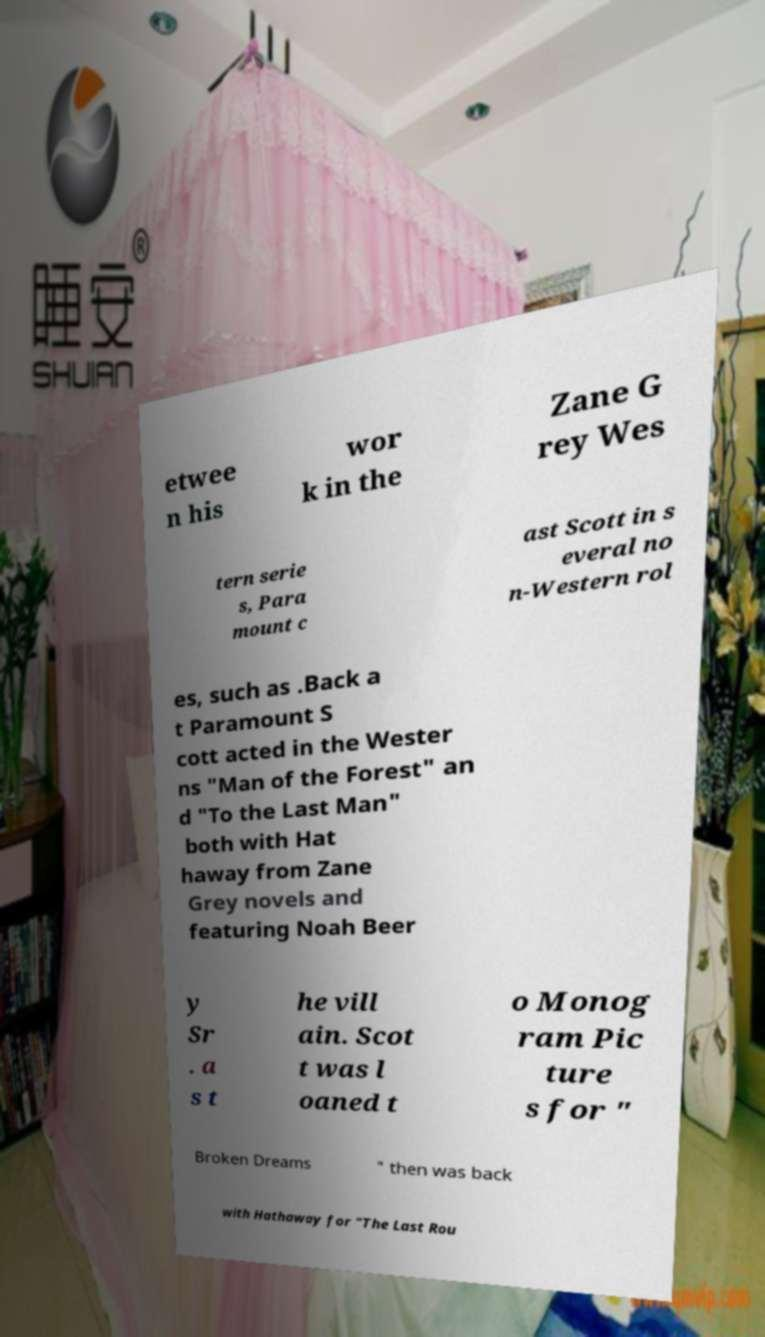There's text embedded in this image that I need extracted. Can you transcribe it verbatim? etwee n his wor k in the Zane G rey Wes tern serie s, Para mount c ast Scott in s everal no n-Western rol es, such as .Back a t Paramount S cott acted in the Wester ns "Man of the Forest" an d "To the Last Man" both with Hat haway from Zane Grey novels and featuring Noah Beer y Sr . a s t he vill ain. Scot t was l oaned t o Monog ram Pic ture s for " Broken Dreams " then was back with Hathaway for "The Last Rou 